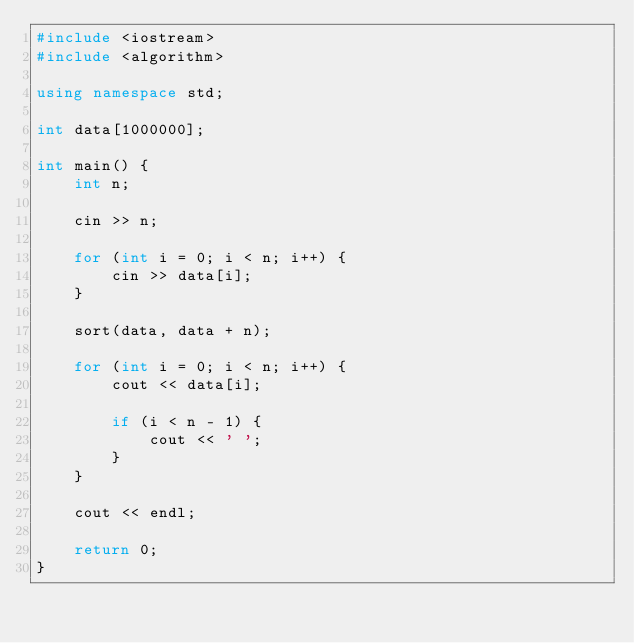Convert code to text. <code><loc_0><loc_0><loc_500><loc_500><_C++_>#include <iostream>
#include <algorithm>

using namespace std;

int data[1000000];

int main() {
	int n;

	cin >> n;

	for (int i = 0; i < n; i++) {
		cin >> data[i];
	}

	sort(data, data + n);

	for (int i = 0; i < n; i++) {
		cout << data[i];

		if (i < n - 1) {
			cout << ' ';
		}
	}

	cout << endl;

	return 0;
}</code> 